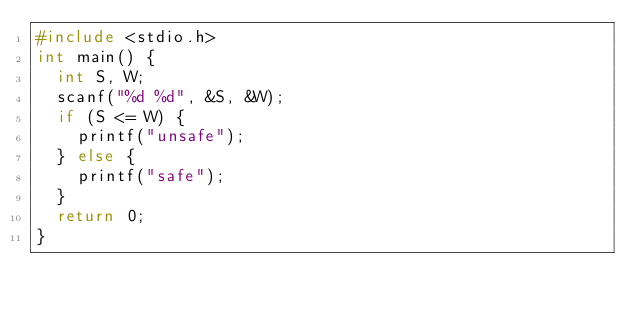<code> <loc_0><loc_0><loc_500><loc_500><_C_>#include <stdio.h>
int main() {
  int S, W;
  scanf("%d %d", &S, &W);
  if (S <= W) {
    printf("unsafe");
  } else {
    printf("safe");
  }
  return 0;
}</code> 